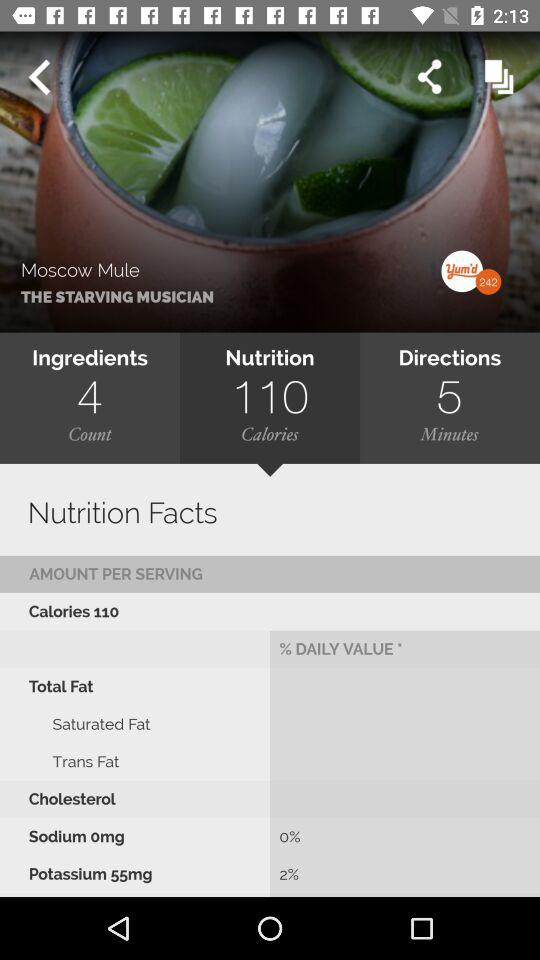How many ingredients are in this recipe?
Answer the question using a single word or phrase. 4 